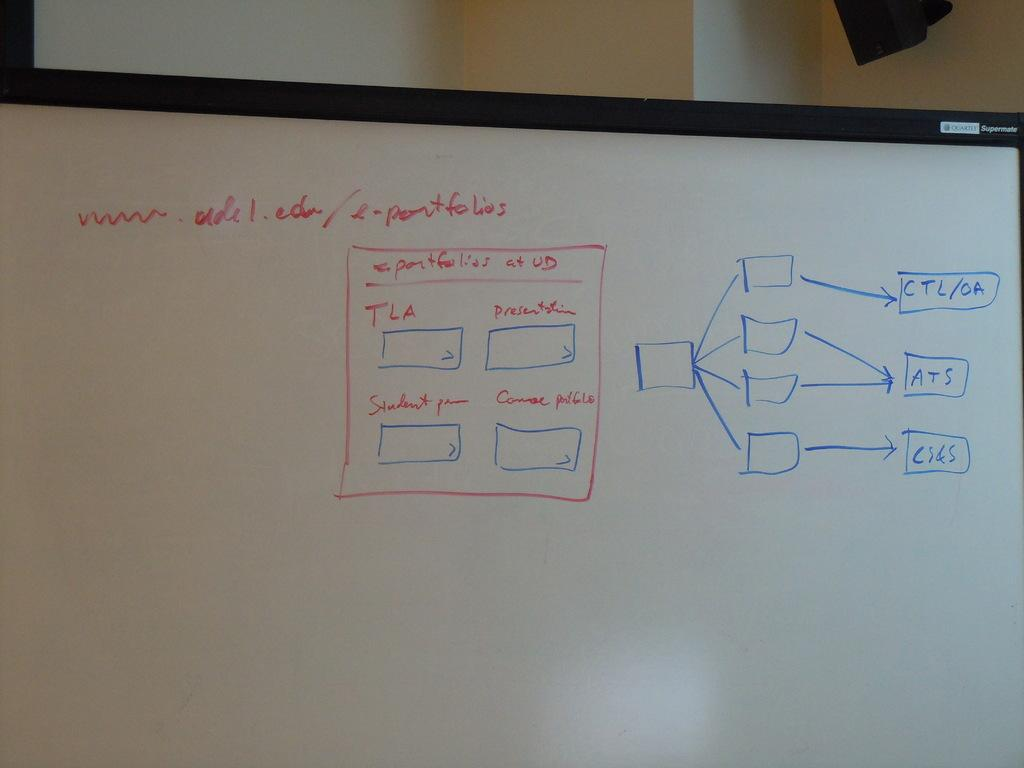<image>
Share a concise interpretation of the image provided. a white board with e-portfolios written on it 